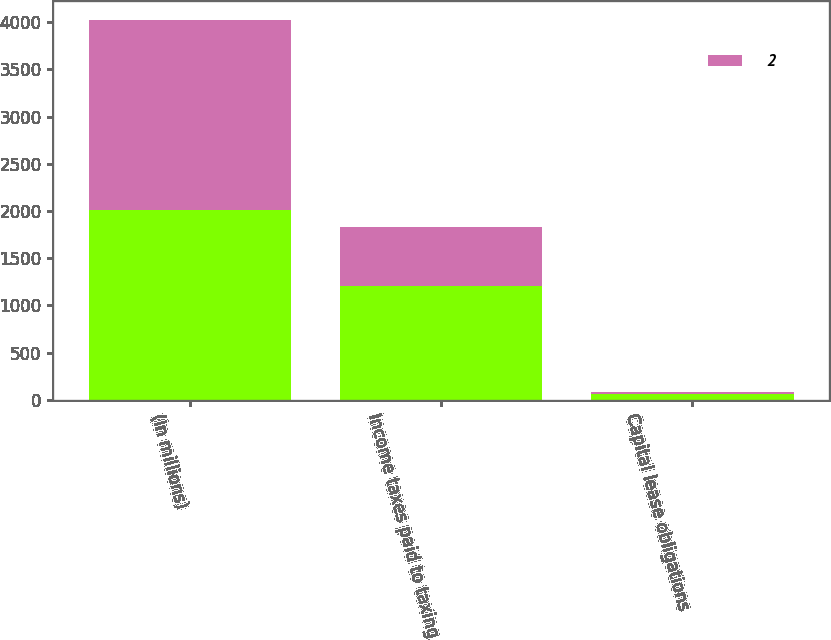<chart> <loc_0><loc_0><loc_500><loc_500><stacked_bar_chart><ecel><fcel>(In millions)<fcel>Income taxes paid to taxing<fcel>Capital lease obligations<nl><fcel>nan<fcel>2012<fcel>1211<fcel>62<nl><fcel>2<fcel>2011<fcel>617<fcel>26<nl></chart> 